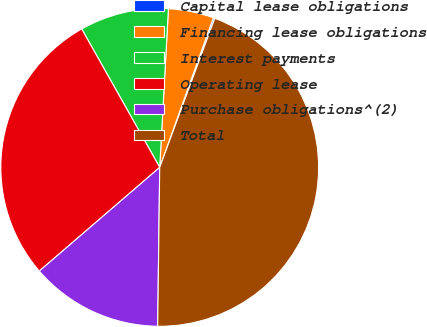Convert chart to OTSL. <chart><loc_0><loc_0><loc_500><loc_500><pie_chart><fcel>Capital lease obligations<fcel>Financing lease obligations<fcel>Interest payments<fcel>Operating lease<fcel>Purchase obligations^(2)<fcel>Total<nl><fcel>0.16%<fcel>4.6%<fcel>9.04%<fcel>28.14%<fcel>13.48%<fcel>44.56%<nl></chart> 